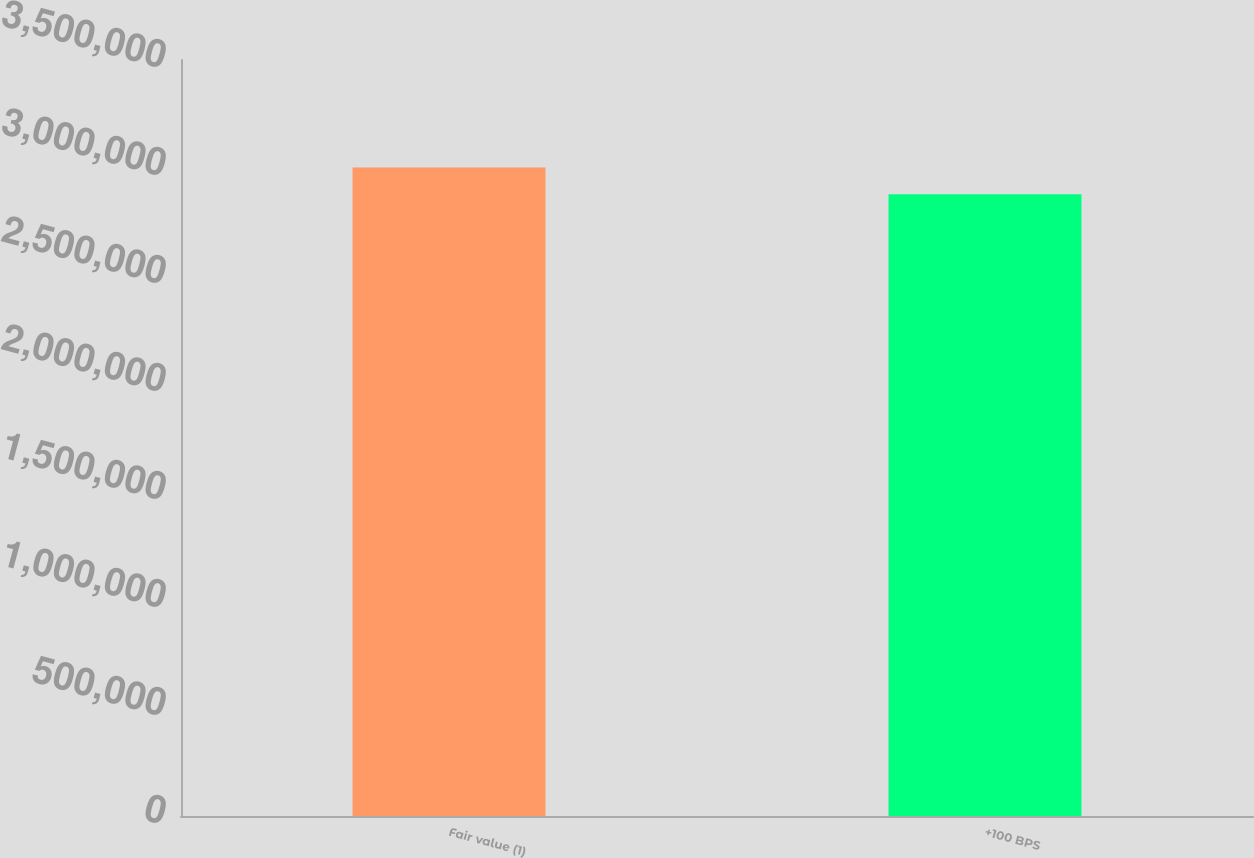Convert chart. <chart><loc_0><loc_0><loc_500><loc_500><bar_chart><fcel>Fair value (1)<fcel>+100 BPS<nl><fcel>3.00209e+06<fcel>2.87793e+06<nl></chart> 